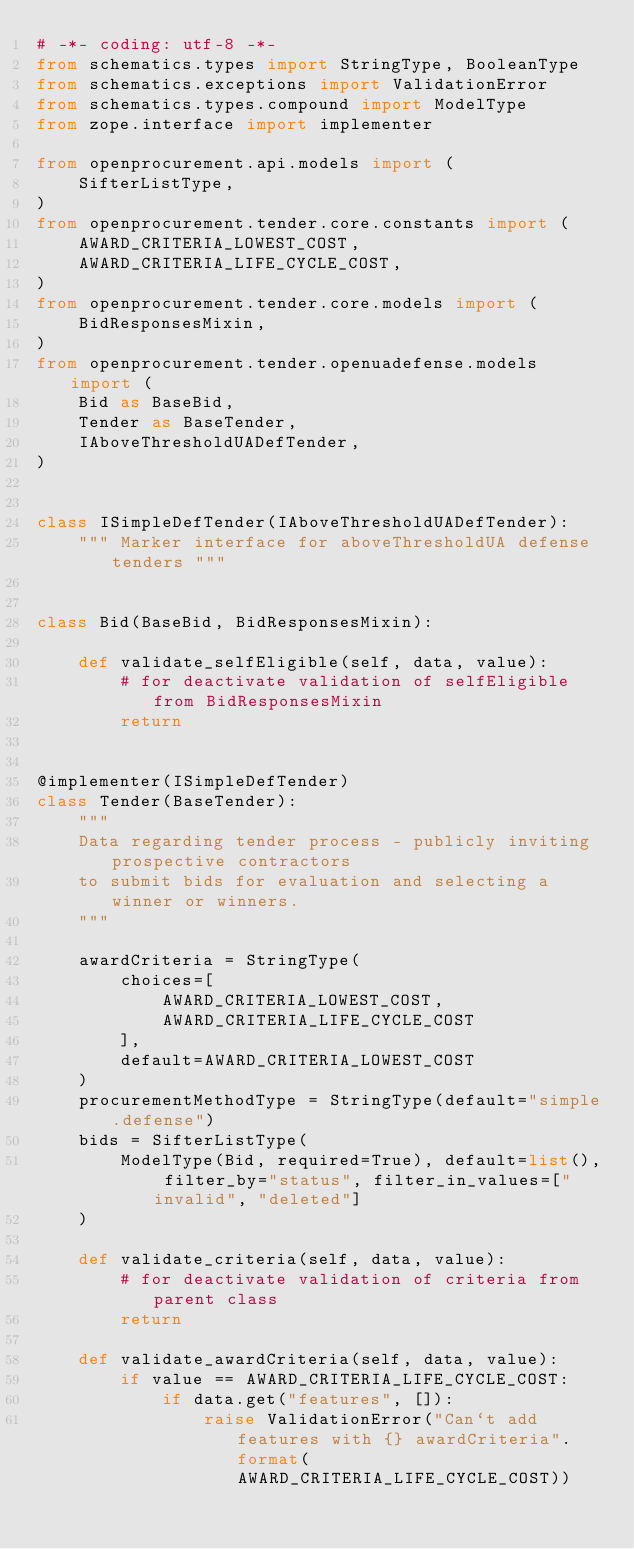<code> <loc_0><loc_0><loc_500><loc_500><_Python_># -*- coding: utf-8 -*-
from schematics.types import StringType, BooleanType
from schematics.exceptions import ValidationError
from schematics.types.compound import ModelType
from zope.interface import implementer

from openprocurement.api.models import (
    SifterListType,
)
from openprocurement.tender.core.constants import (
    AWARD_CRITERIA_LOWEST_COST,
    AWARD_CRITERIA_LIFE_CYCLE_COST,
)
from openprocurement.tender.core.models import (
    BidResponsesMixin,
)
from openprocurement.tender.openuadefense.models import (
    Bid as BaseBid,
    Tender as BaseTender,
    IAboveThresholdUADefTender,
)


class ISimpleDefTender(IAboveThresholdUADefTender):
    """ Marker interface for aboveThresholdUA defense tenders """


class Bid(BaseBid, BidResponsesMixin):

    def validate_selfEligible(self, data, value):
        # for deactivate validation of selfEligible from BidResponsesMixin
        return


@implementer(ISimpleDefTender)
class Tender(BaseTender):
    """
    Data regarding tender process - publicly inviting prospective contractors
    to submit bids for evaluation and selecting a winner or winners.
    """

    awardCriteria = StringType(
        choices=[
            AWARD_CRITERIA_LOWEST_COST,
            AWARD_CRITERIA_LIFE_CYCLE_COST
        ],
        default=AWARD_CRITERIA_LOWEST_COST
    )
    procurementMethodType = StringType(default="simple.defense")
    bids = SifterListType(
        ModelType(Bid, required=True), default=list(), filter_by="status", filter_in_values=["invalid", "deleted"]
    )

    def validate_criteria(self, data, value):
        # for deactivate validation of criteria from parent class
        return

    def validate_awardCriteria(self, data, value):
        if value == AWARD_CRITERIA_LIFE_CYCLE_COST:
            if data.get("features", []):
                raise ValidationError("Can`t add features with {} awardCriteria".format(AWARD_CRITERIA_LIFE_CYCLE_COST))
</code> 